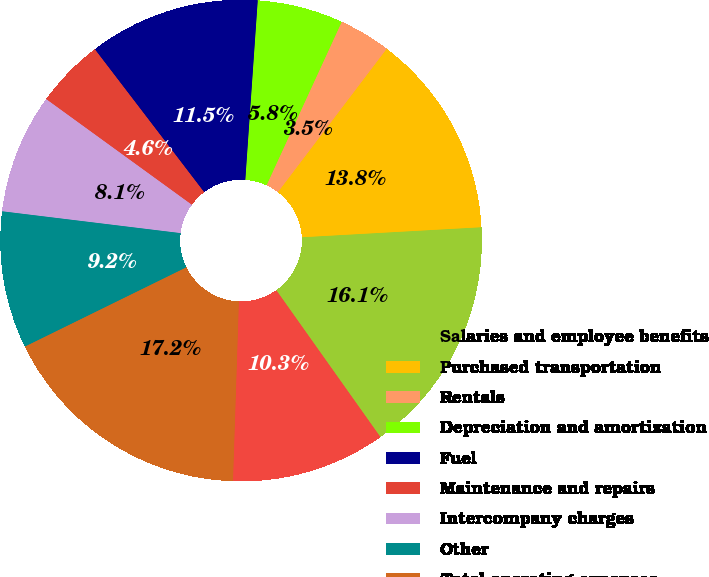Convert chart. <chart><loc_0><loc_0><loc_500><loc_500><pie_chart><fcel>Salaries and employee benefits<fcel>Purchased transportation<fcel>Rentals<fcel>Depreciation and amortization<fcel>Fuel<fcel>Maintenance and repairs<fcel>Intercompany charges<fcel>Other<fcel>Total operating expenses<fcel>Operating income<nl><fcel>16.07%<fcel>13.78%<fcel>3.47%<fcel>5.76%<fcel>11.49%<fcel>4.62%<fcel>8.05%<fcel>9.2%<fcel>17.21%<fcel>10.34%<nl></chart> 